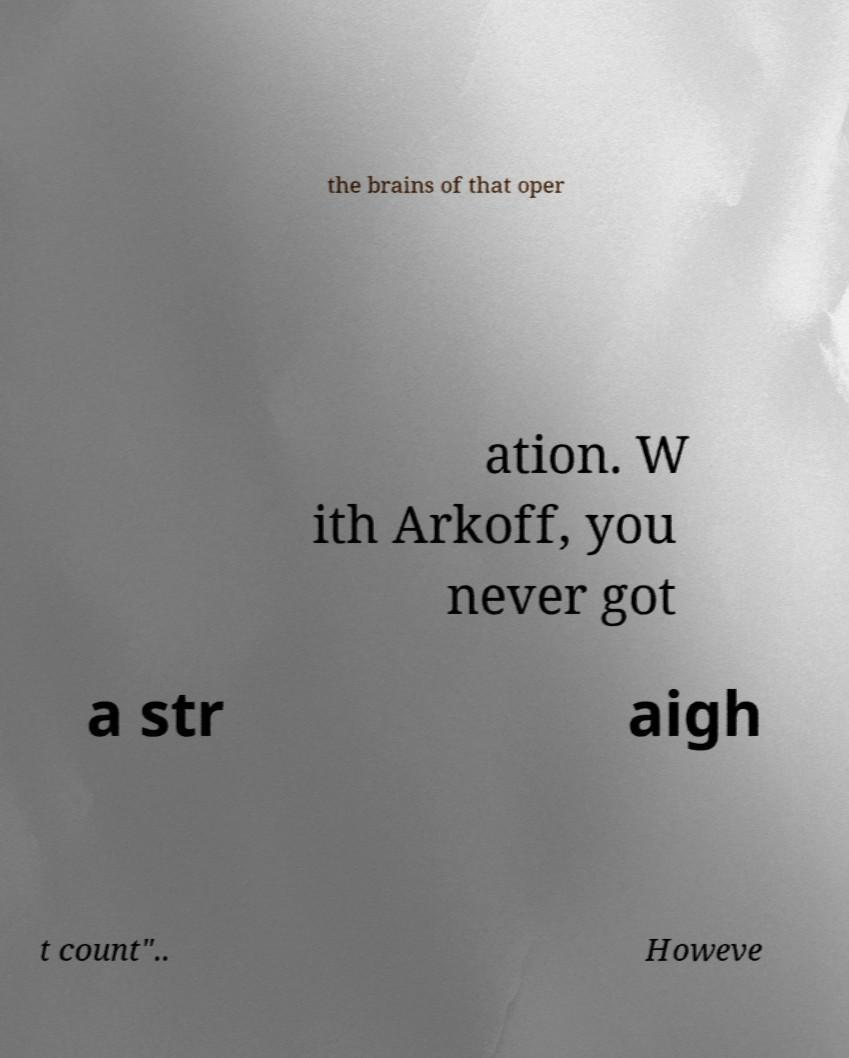Please identify and transcribe the text found in this image. the brains of that oper ation. W ith Arkoff, you never got a str aigh t count".. Howeve 